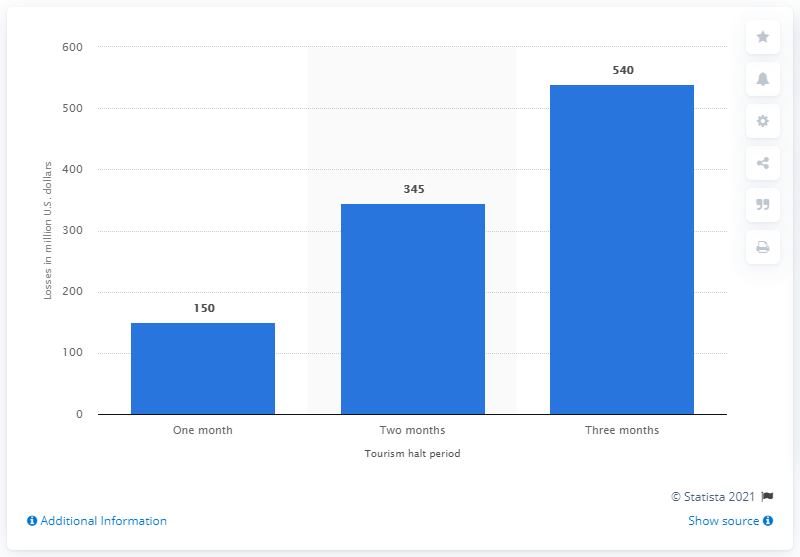Indicate a few pertinent items in this graphic. If the Ecuadorian travel and tourism sector lost 150 million dollars in one month, it would result in a significant loss for the industry. The tourism industry in Ecuador could potentially lose an estimated $540 million if the COVID-19 outbreak occurs. 